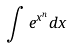Convert formula to latex. <formula><loc_0><loc_0><loc_500><loc_500>\int e ^ { x ^ { n } } d x</formula> 